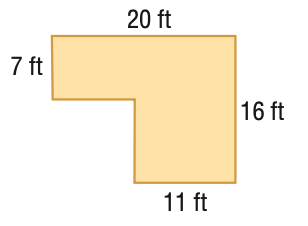Question: Find the area of the figure. Round to the nearest tenth if necessary.
Choices:
A. 81
B. 119.5
C. 239
D. 320
Answer with the letter. Answer: C 